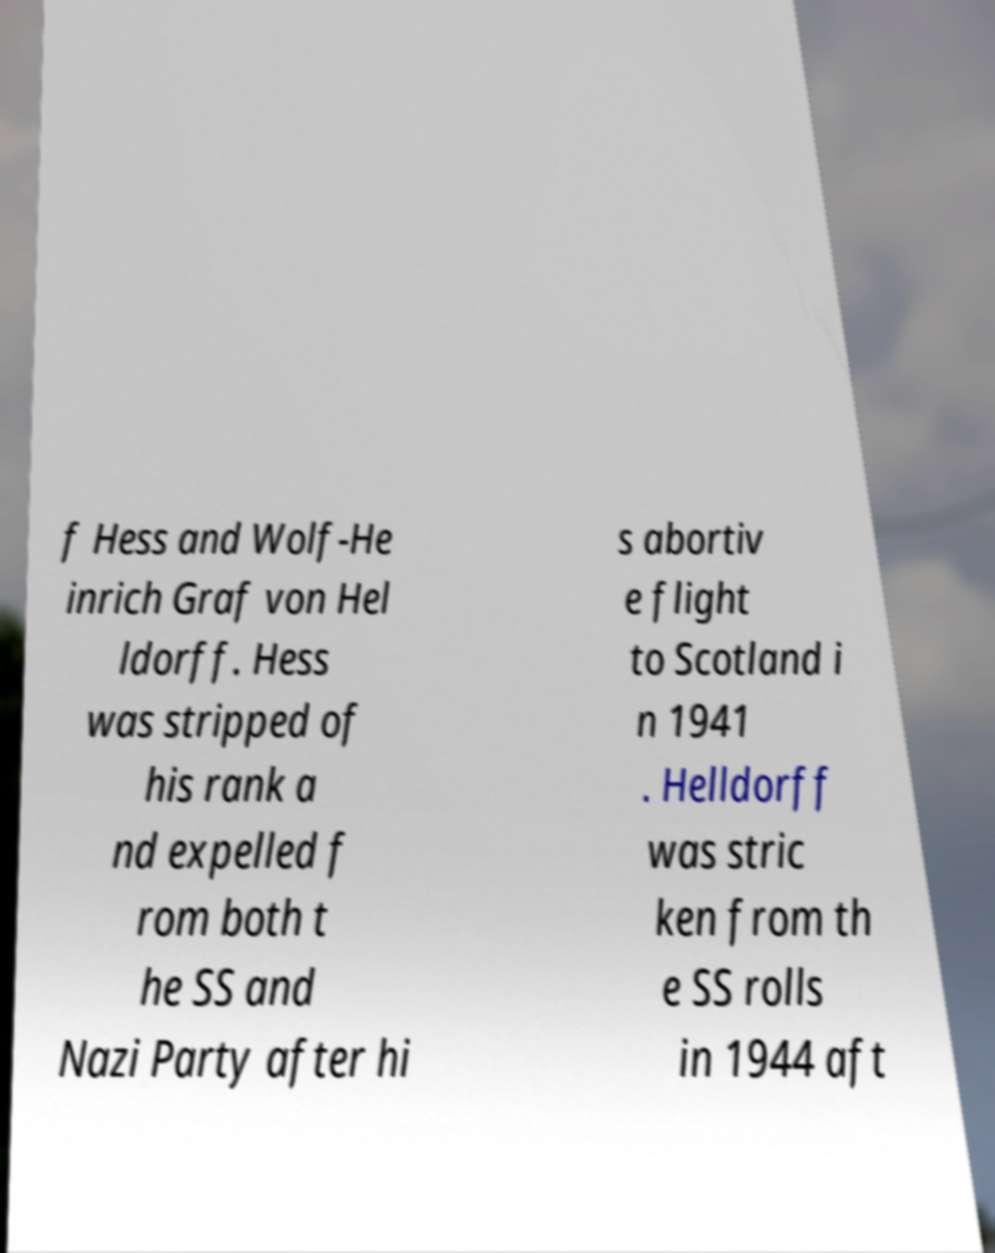Can you accurately transcribe the text from the provided image for me? f Hess and Wolf-He inrich Graf von Hel ldorff. Hess was stripped of his rank a nd expelled f rom both t he SS and Nazi Party after hi s abortiv e flight to Scotland i n 1941 . Helldorff was stric ken from th e SS rolls in 1944 aft 